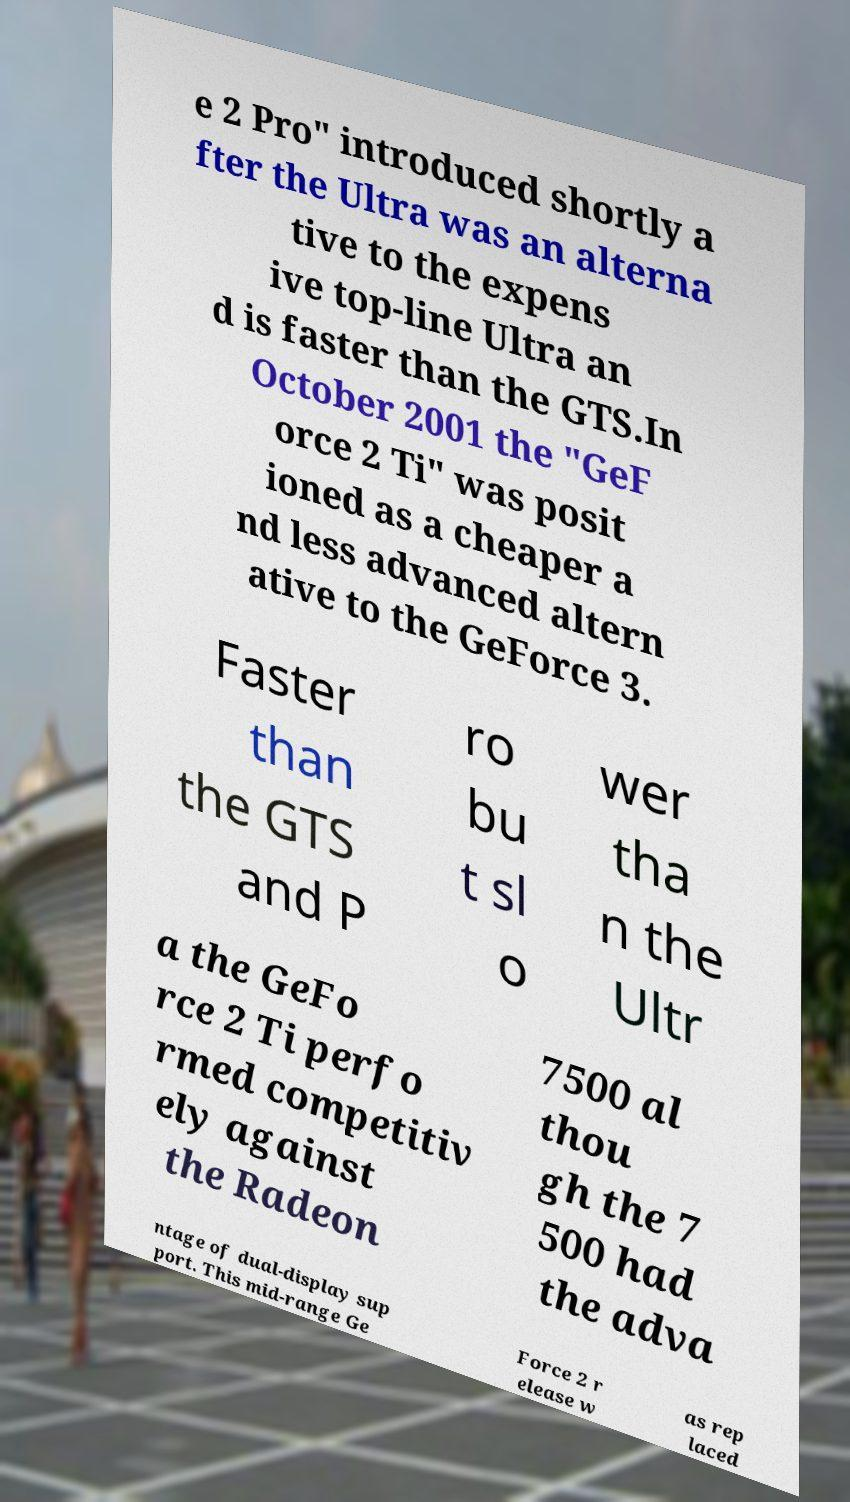For documentation purposes, I need the text within this image transcribed. Could you provide that? e 2 Pro" introduced shortly a fter the Ultra was an alterna tive to the expens ive top-line Ultra an d is faster than the GTS.In October 2001 the "GeF orce 2 Ti" was posit ioned as a cheaper a nd less advanced altern ative to the GeForce 3. Faster than the GTS and P ro bu t sl o wer tha n the Ultr a the GeFo rce 2 Ti perfo rmed competitiv ely against the Radeon 7500 al thou gh the 7 500 had the adva ntage of dual-display sup port. This mid-range Ge Force 2 r elease w as rep laced 